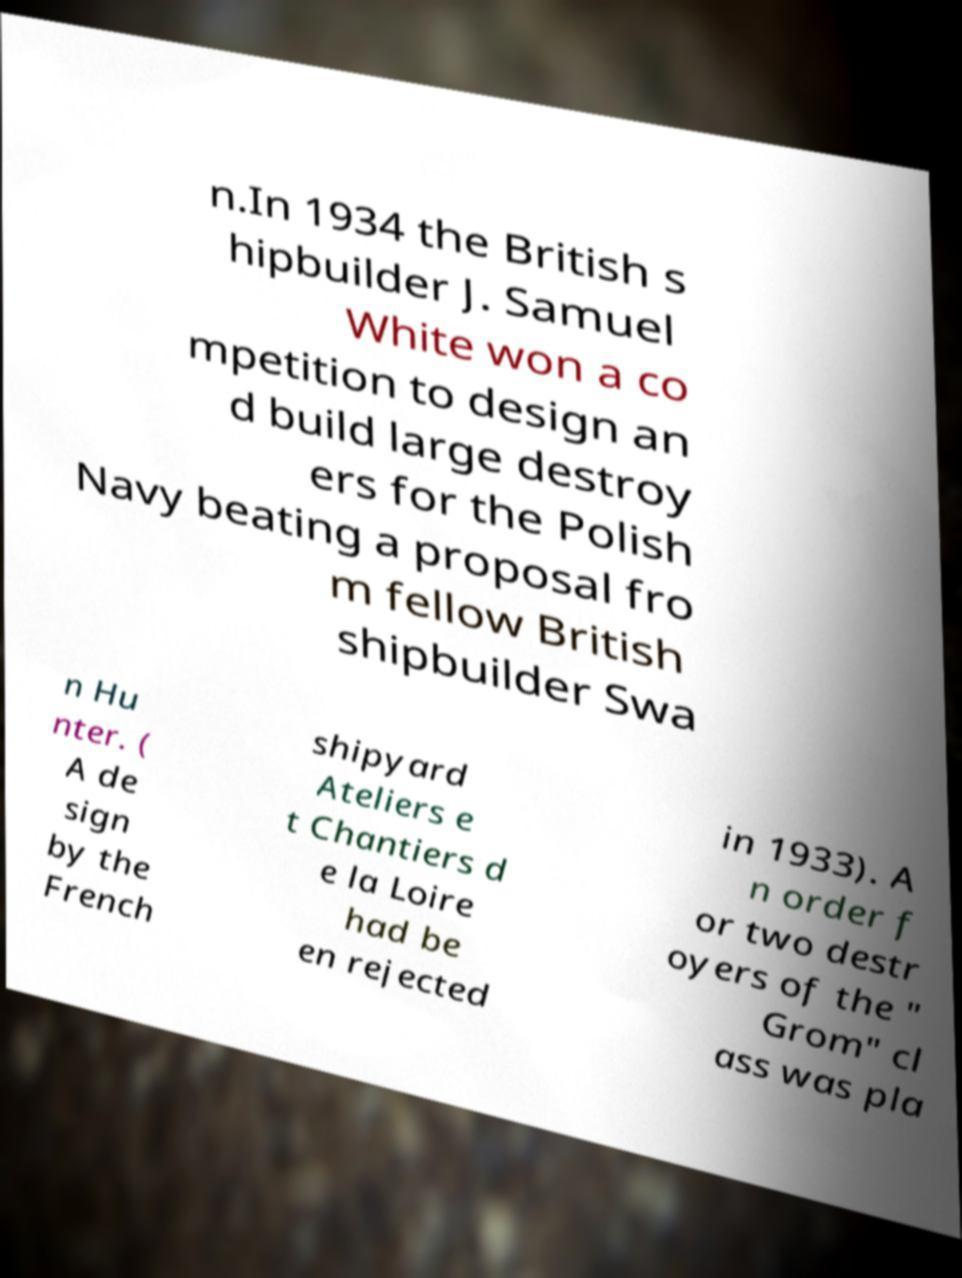What messages or text are displayed in this image? I need them in a readable, typed format. n.In 1934 the British s hipbuilder J. Samuel White won a co mpetition to design an d build large destroy ers for the Polish Navy beating a proposal fro m fellow British shipbuilder Swa n Hu nter. ( A de sign by the French shipyard Ateliers e t Chantiers d e la Loire had be en rejected in 1933). A n order f or two destr oyers of the " Grom" cl ass was pla 